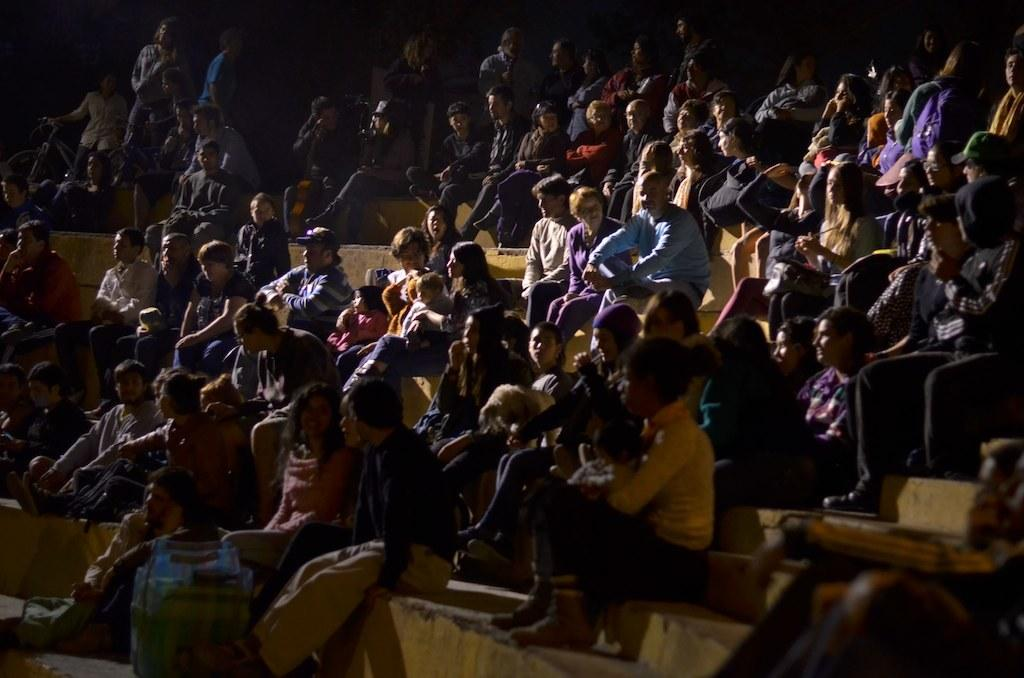What are the people in the image doing? There are people seated and standing in the image. Are there any interactions between the people in the image? Yes, some people are holding kids with their hands. What type of design can be seen on the tub in the image? There is no tub present in the image. What is the source of humor in the image? There is no humor depicted in the image; it simply shows people seated, standing, and holding kids. 